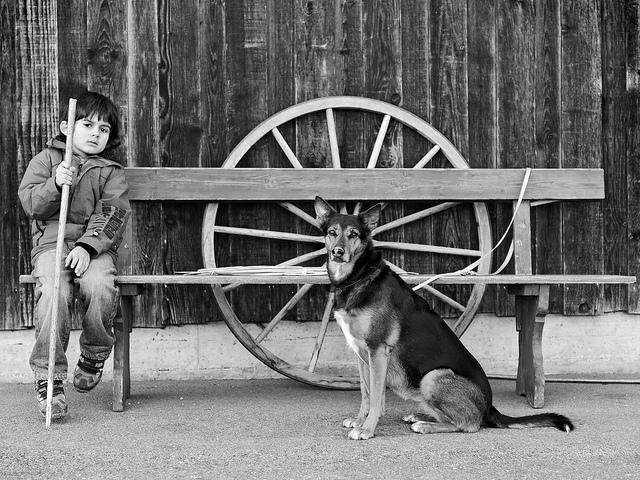What is the wheel called that's behind the bench? Please explain your reasoning. wagon wheel. There is a wagon wheel behind the dog since it's so large. 